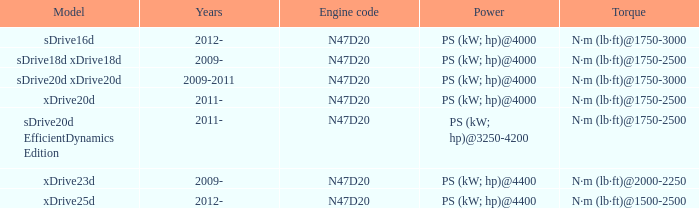What model is the n·m (lb·ft)@1500-2500 torque? Xdrive25d. 